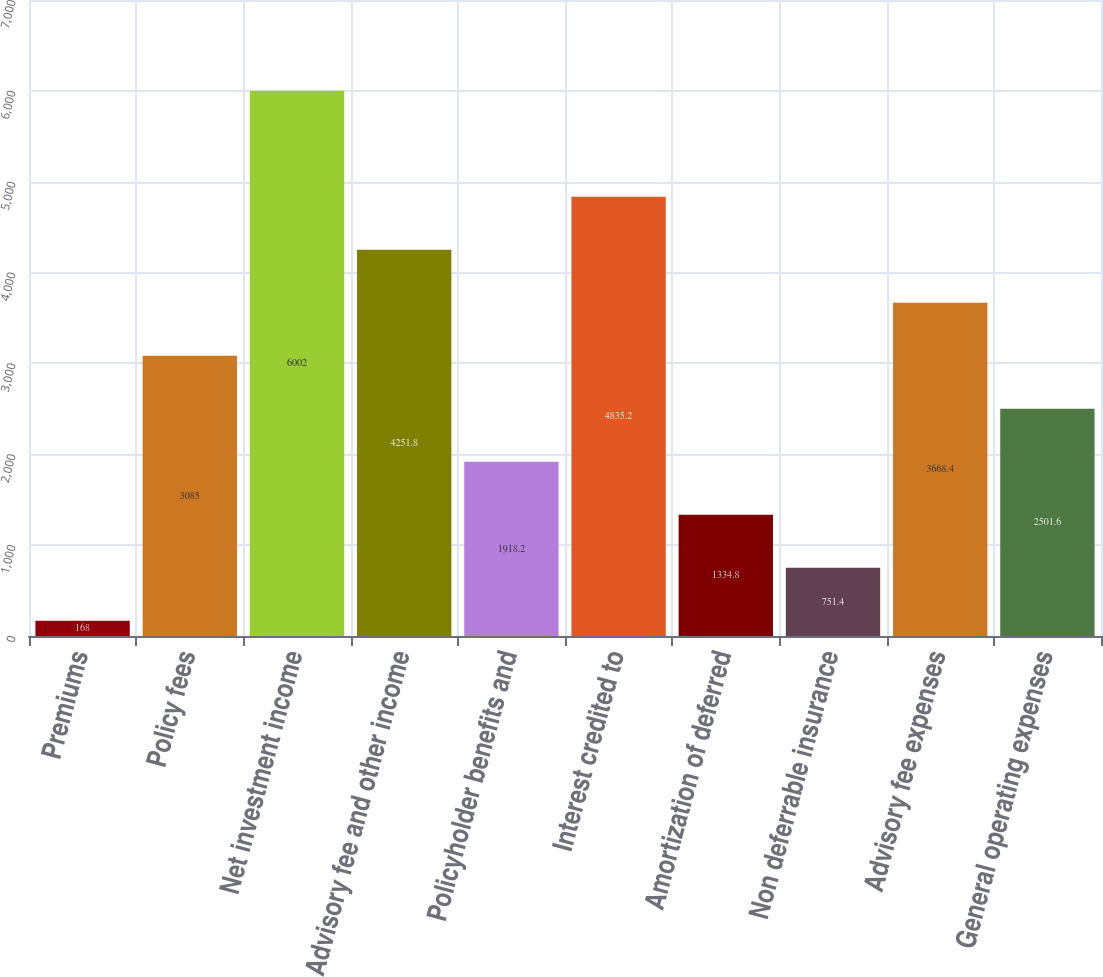Convert chart to OTSL. <chart><loc_0><loc_0><loc_500><loc_500><bar_chart><fcel>Premiums<fcel>Policy fees<fcel>Net investment income<fcel>Advisory fee and other income<fcel>Policyholder benefits and<fcel>Interest credited to<fcel>Amortization of deferred<fcel>Non deferrable insurance<fcel>Advisory fee expenses<fcel>General operating expenses<nl><fcel>168<fcel>3085<fcel>6002<fcel>4251.8<fcel>1918.2<fcel>4835.2<fcel>1334.8<fcel>751.4<fcel>3668.4<fcel>2501.6<nl></chart> 